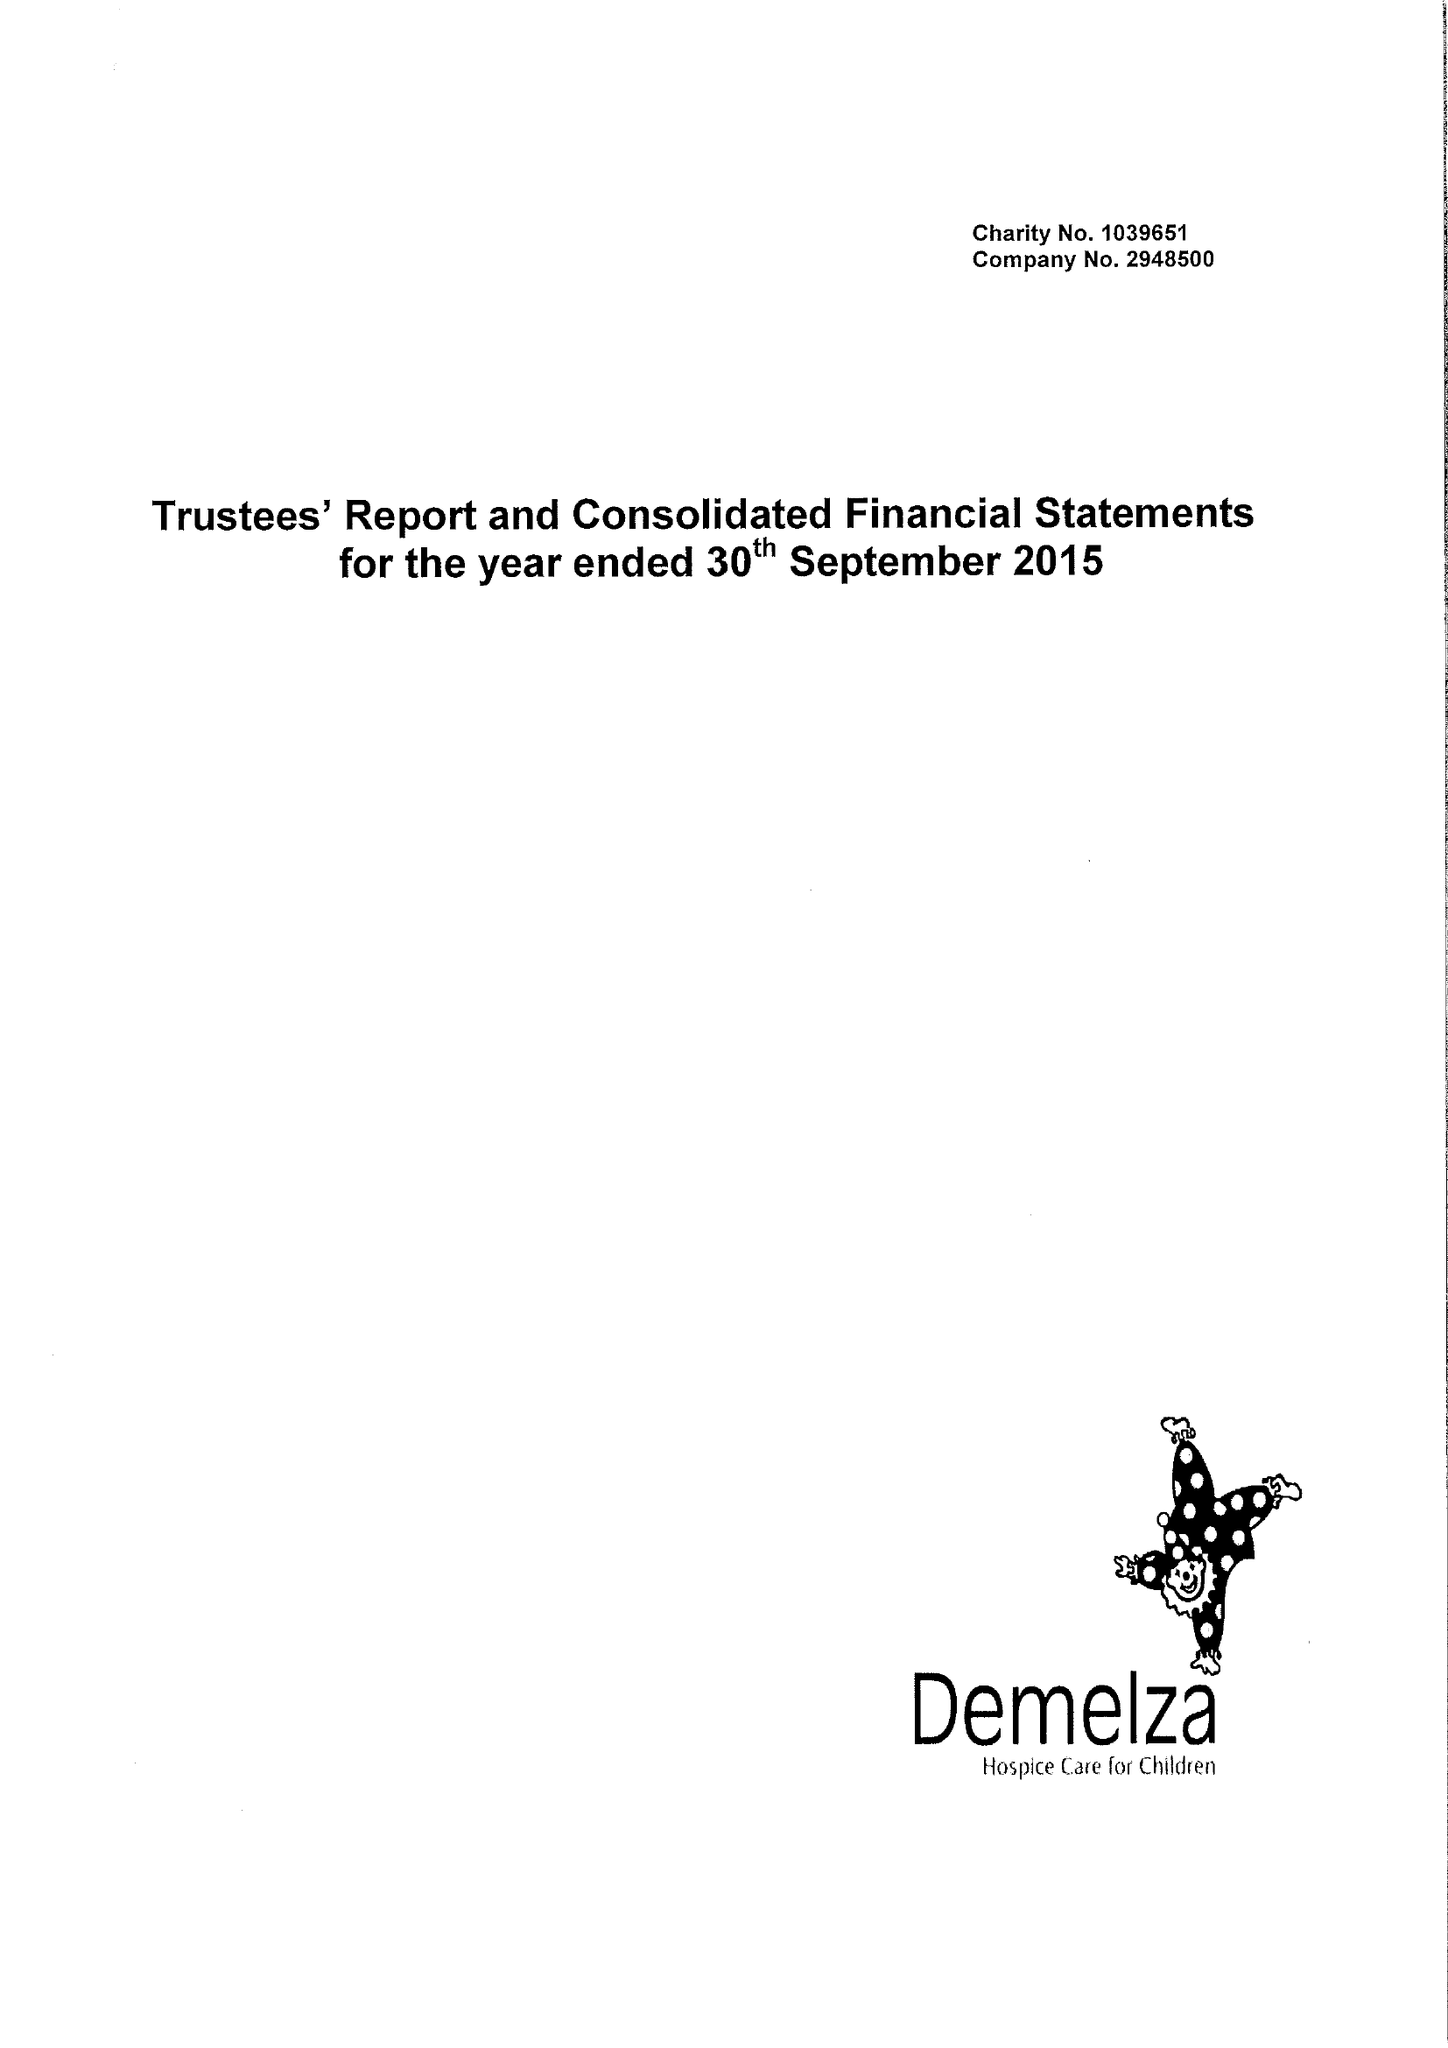What is the value for the address__post_town?
Answer the question using a single word or phrase. SITTINGBOURNE 